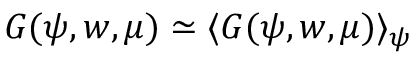Convert formula to latex. <formula><loc_0><loc_0><loc_500><loc_500>G ( \psi , w , \mu ) \simeq \langle G ( \psi , w , \mu ) \rangle _ { \psi }</formula> 